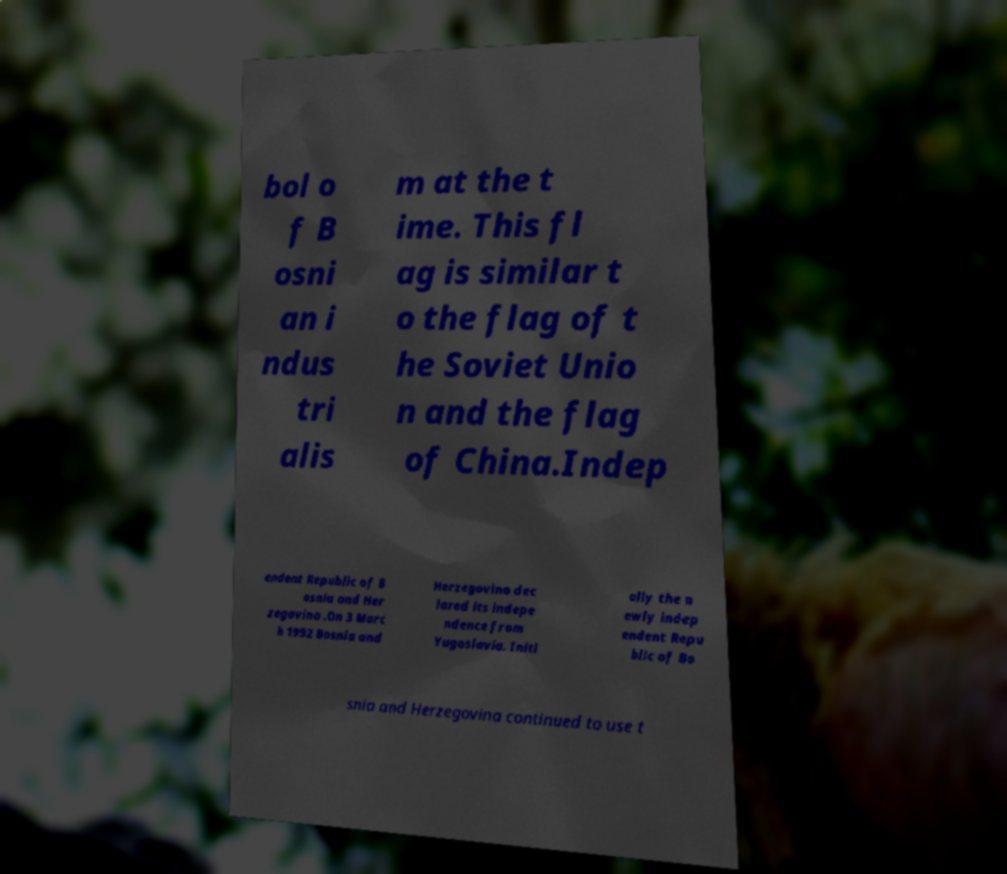Please read and relay the text visible in this image. What does it say? bol o f B osni an i ndus tri alis m at the t ime. This fl ag is similar t o the flag of t he Soviet Unio n and the flag of China.Indep endent Republic of B osnia and Her zegovina .On 3 Marc h 1992 Bosnia and Herzegovina dec lared its indepe ndence from Yugoslavia. Initi ally the n ewly indep endent Repu blic of Bo snia and Herzegovina continued to use t 